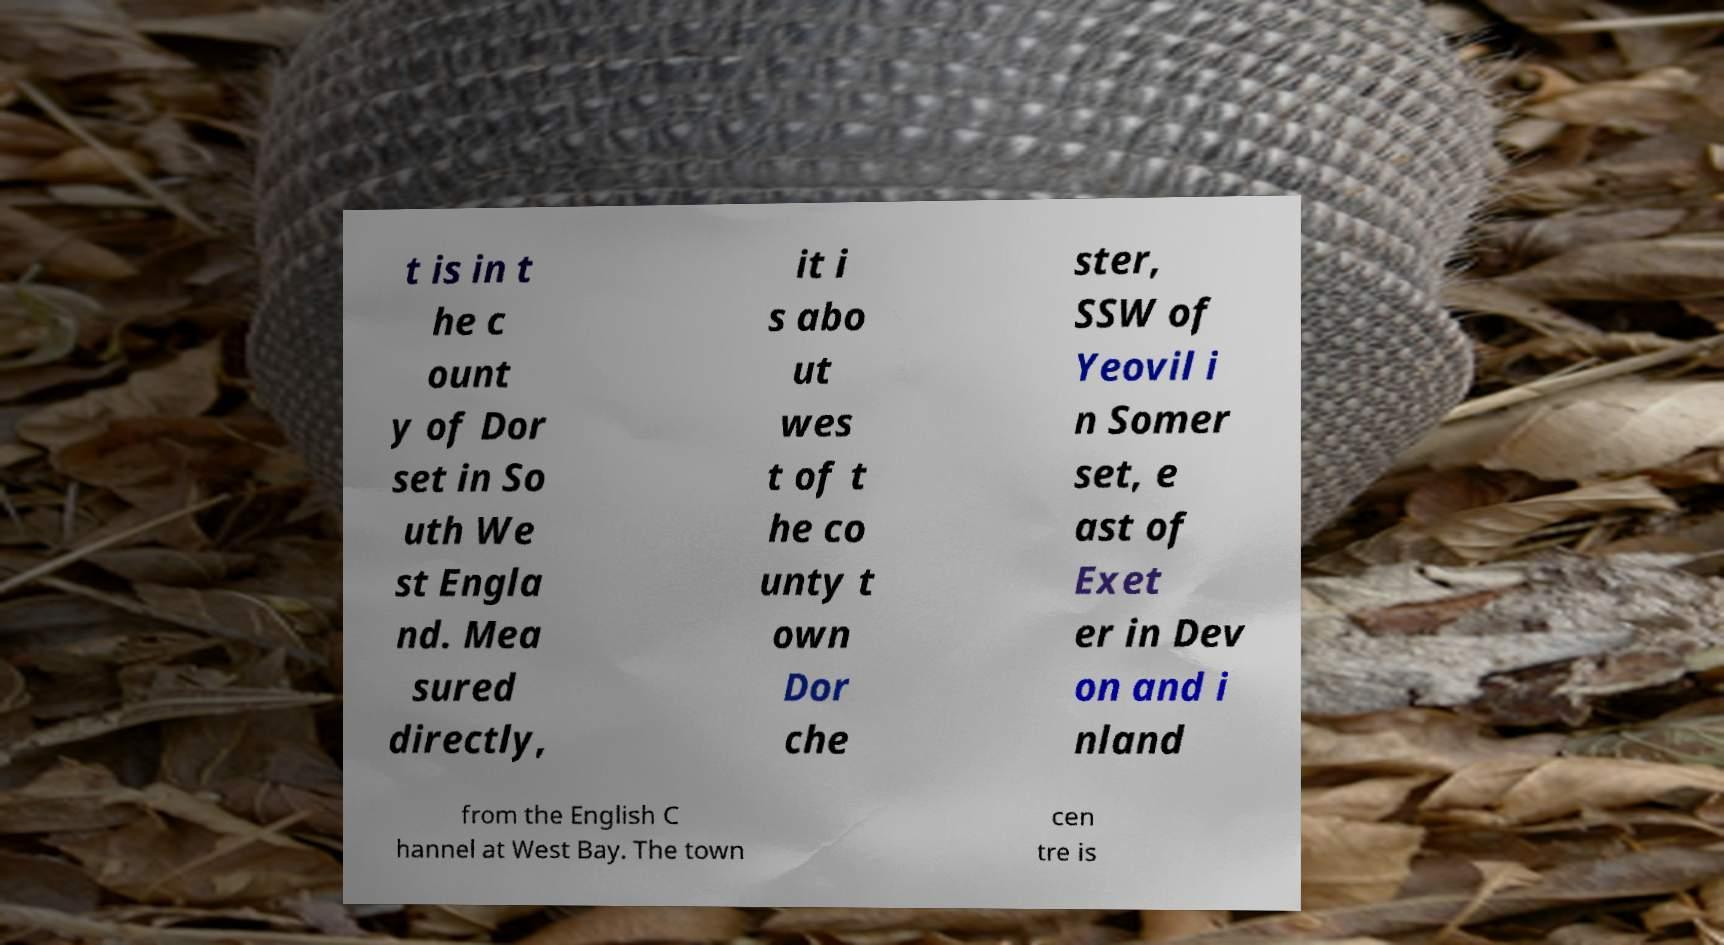Can you read and provide the text displayed in the image?This photo seems to have some interesting text. Can you extract and type it out for me? t is in t he c ount y of Dor set in So uth We st Engla nd. Mea sured directly, it i s abo ut wes t of t he co unty t own Dor che ster, SSW of Yeovil i n Somer set, e ast of Exet er in Dev on and i nland from the English C hannel at West Bay. The town cen tre is 